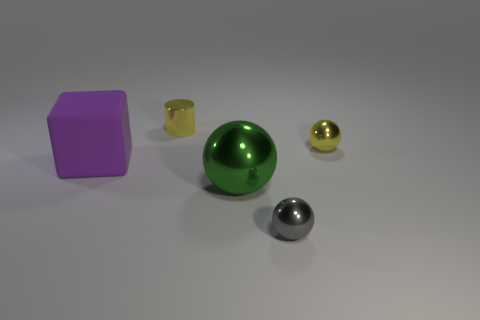Subtract all gray spheres. How many spheres are left? 2 Add 4 balls. How many objects exist? 9 Subtract all gray spheres. How many spheres are left? 2 Subtract all cylinders. How many objects are left? 4 Add 3 big gray cylinders. How many big gray cylinders exist? 3 Subtract 0 cyan cylinders. How many objects are left? 5 Subtract all blue balls. Subtract all green cylinders. How many balls are left? 3 Subtract all purple things. Subtract all brown rubber cylinders. How many objects are left? 4 Add 4 large metallic spheres. How many large metallic spheres are left? 5 